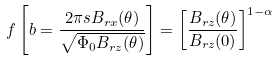<formula> <loc_0><loc_0><loc_500><loc_500>f \left [ b = \frac { 2 \pi s B _ { r x } ( \theta ) } { \sqrt { \Phi _ { 0 } B _ { r z } ( \theta ) } } \right ] = \left [ \frac { B _ { r z } ( \theta ) } { B _ { r z } ( 0 ) } \right ] ^ { 1 - \alpha }</formula> 